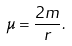Convert formula to latex. <formula><loc_0><loc_0><loc_500><loc_500>\mu = \frac { 2 m } r .</formula> 